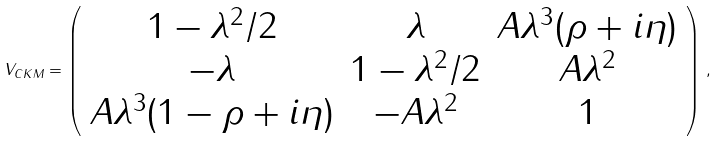<formula> <loc_0><loc_0><loc_500><loc_500>V _ { C K M } = \left ( \begin{array} { c c c } 1 - \lambda ^ { 2 } / 2 & \lambda & A \lambda ^ { 3 } ( \rho + i \eta ) \\ - \lambda & 1 - \lambda ^ { 2 } / 2 & A \lambda ^ { 2 } \\ A \lambda ^ { 3 } ( 1 - \rho + i \eta ) & - A \lambda ^ { 2 } & 1 \end{array} \right ) \, ,</formula> 